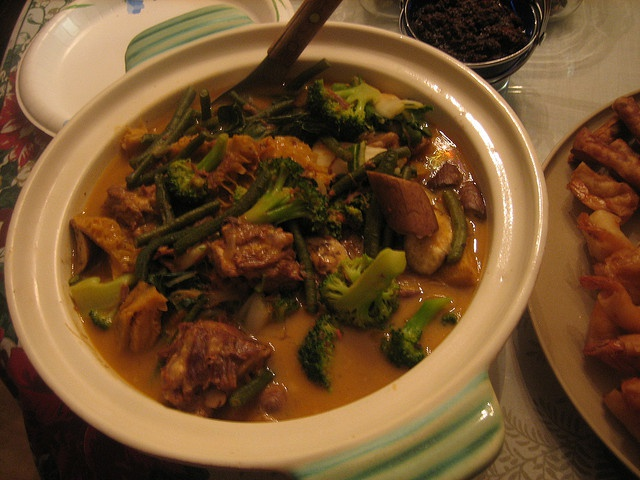Describe the objects in this image and their specific colors. I can see bowl in black, maroon, tan, and brown tones, bowl in black, maroon, and gray tones, broccoli in black, maroon, and olive tones, broccoli in black, olive, and maroon tones, and broccoli in black, olive, and maroon tones in this image. 